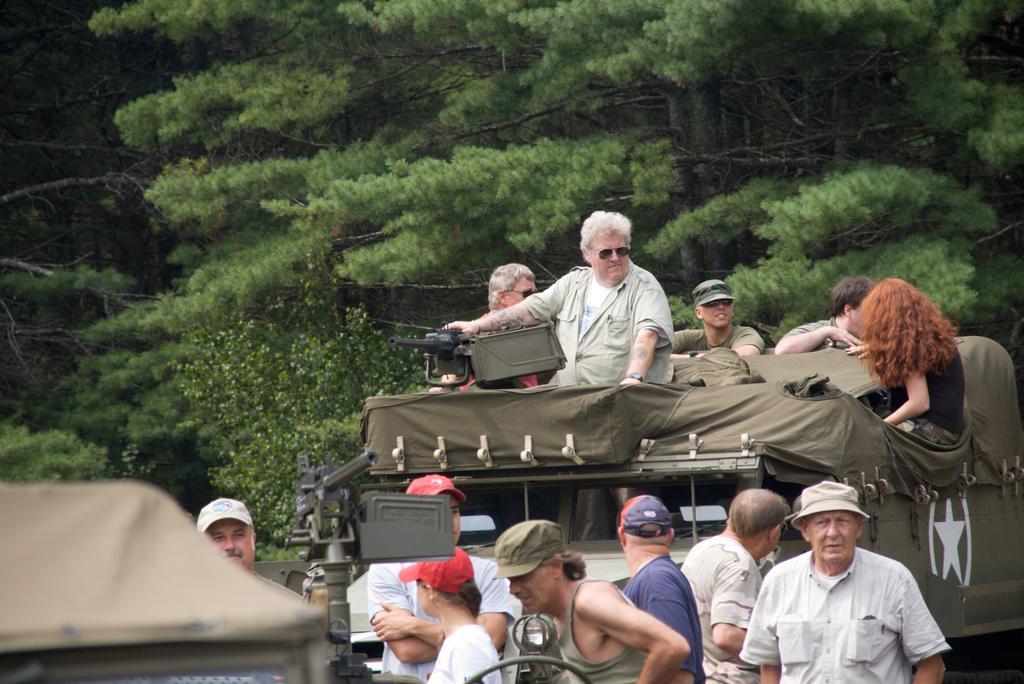Please provide a concise description of this image. In this image, we can see few people. Few are wearing caps. In the middle of the image, we can see few people are riding a vehicle. Background we can see trees. 